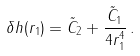Convert formula to latex. <formula><loc_0><loc_0><loc_500><loc_500>\delta h ( r _ { 1 } ) = \tilde { C } _ { 2 } + \frac { \tilde { C } _ { 1 } } { 4 r _ { 1 } ^ { 4 } } \, .</formula> 